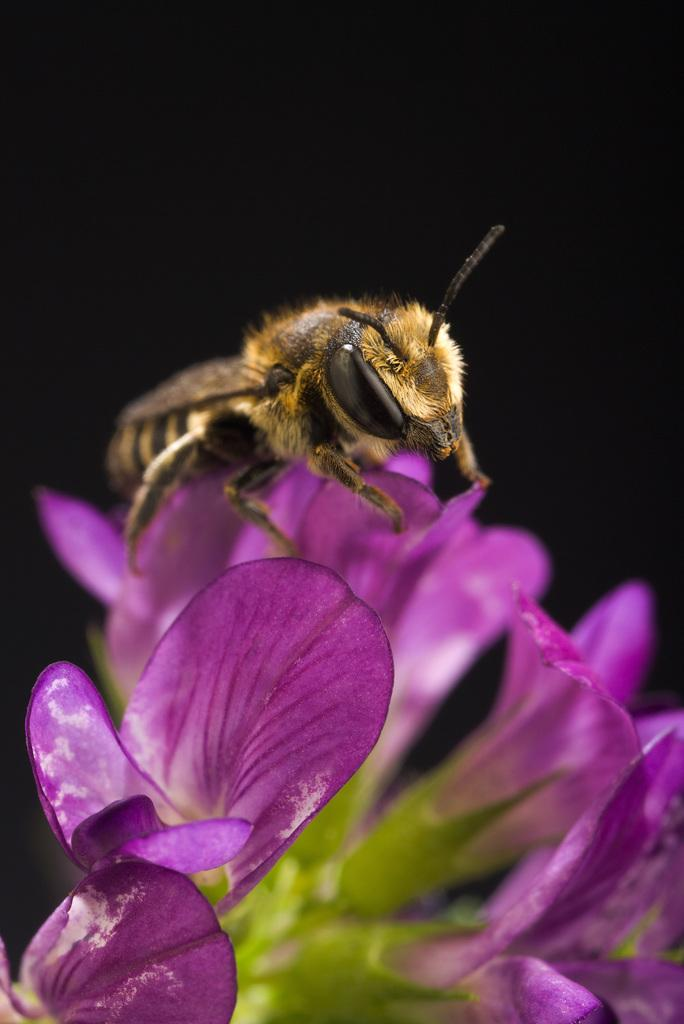What type of creature can be seen in the image? There is an insect in the image. Where is the insect located? The insect is on a flower. What color are the flowers in the image? The flowers are violet in color. How would you describe the lighting in the image? The background of the image appears dark. Is the insect attacking the amusement park in the image? There is no amusement park present in the image, and the insect is not attacking anything. 